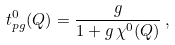Convert formula to latex. <formula><loc_0><loc_0><loc_500><loc_500>t ^ { 0 } _ { p g } ( Q ) = \frac { g } { 1 + g \, \chi ^ { 0 } ( Q ) } \, ,</formula> 